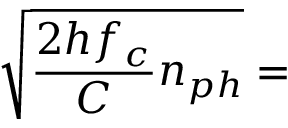Convert formula to latex. <formula><loc_0><loc_0><loc_500><loc_500>\sqrt { \frac { 2 h f _ { c } } { C } n _ { p h } } =</formula> 